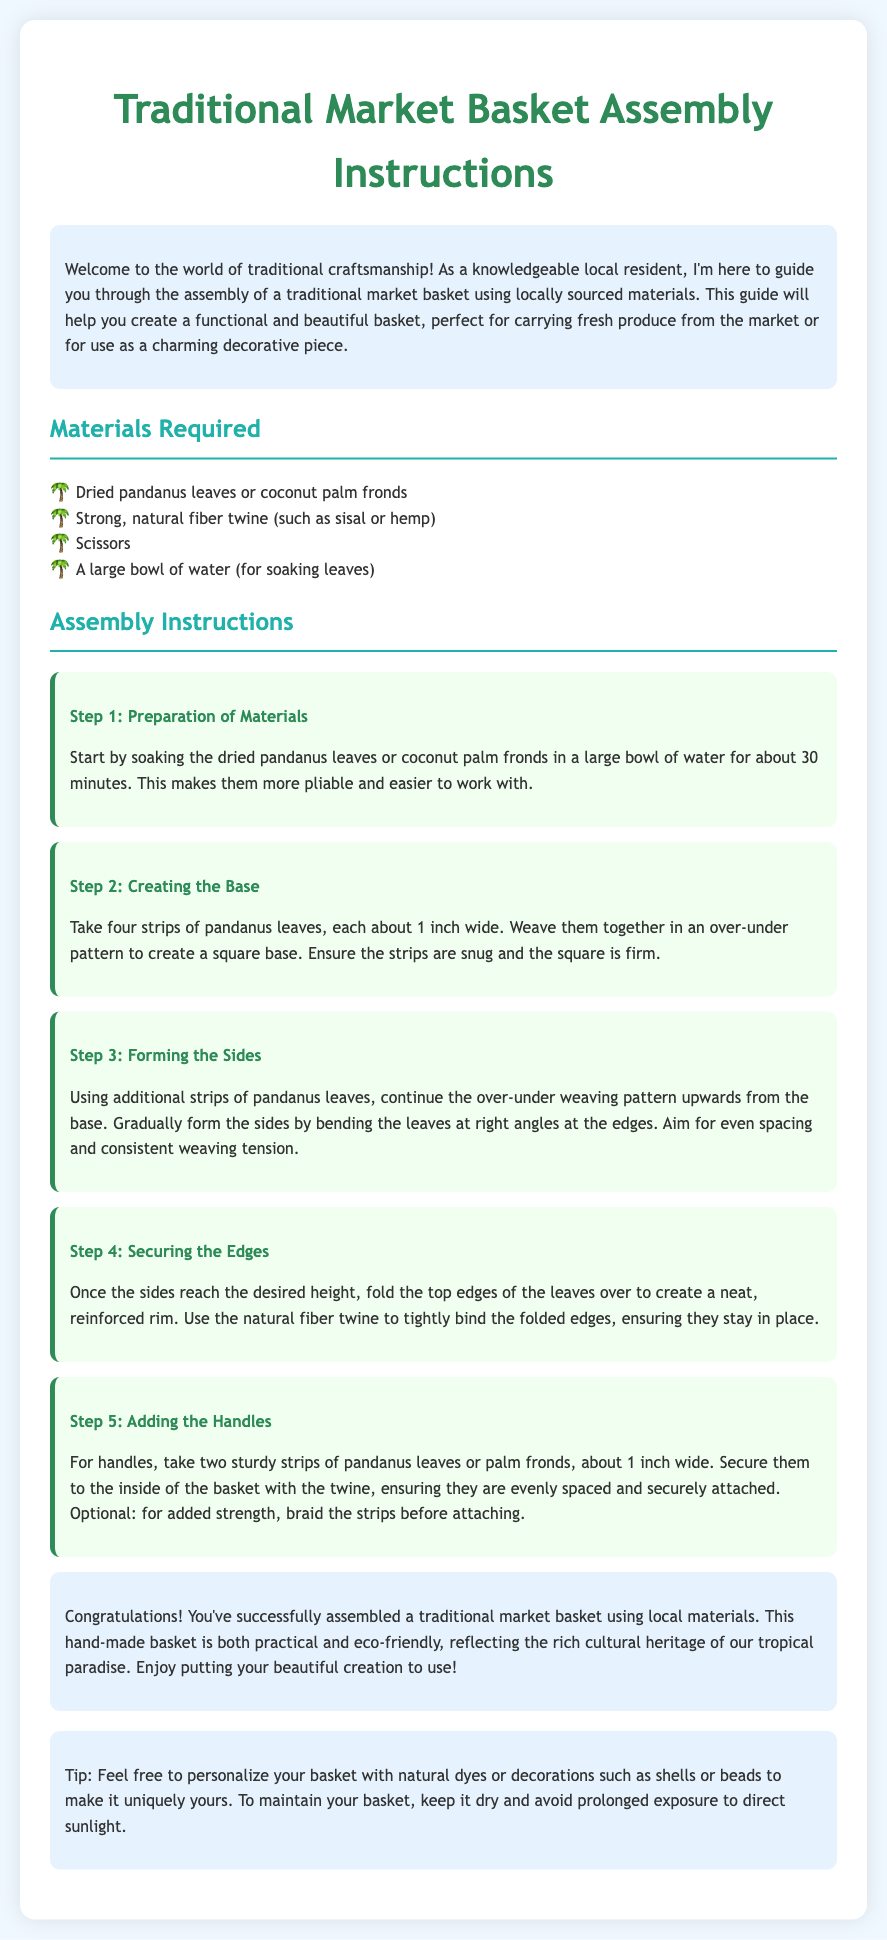What materials are required? The document lists the materials needed to assemble the market basket.
Answer: Dried pandanus leaves or coconut palm fronds, strong natural fiber twine, scissors, a large bowl of water How long should the leaves be soaked? The instructions specify the soaking time for the leaves to prepare them for weaving.
Answer: 30 minutes What is the first step in the assembly process? The document outlines a step-by-step process, starting with preparation.
Answer: Preparation of Materials How many strips are needed for the base? The instructions detail the number of strips to create the base of the basket.
Answer: Four strips What is used to secure the edges? The assembly instructions mention a specific material used to bind the edges of the basket.
Answer: Natural fiber twine What can be added for personalization? The document suggests ways to customize the finished basket.
Answer: Natural dyes or decorations such as shells or beads What should be avoided to maintain the basket? The final tips section includes advice on caring for the basket.
Answer: Prolonged exposure to direct sunlight What is the goal of the basket? The introduction explains the purpose of creating the market basket.
Answer: Functional and beautiful basket What height should the sides reach? The instructions imply that the basket sides should meet a certain visual standard during assembly.
Answer: Desired height 